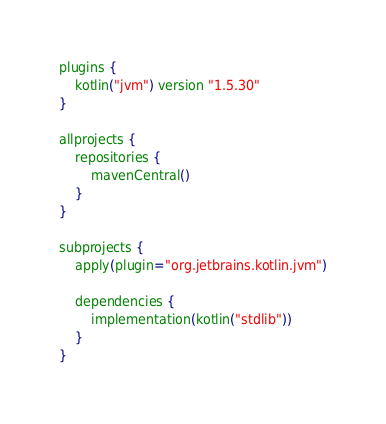Convert code to text. <code><loc_0><loc_0><loc_500><loc_500><_Kotlin_>plugins {
    kotlin("jvm") version "1.5.30"
}

allprojects {
    repositories {
        mavenCentral()
    }
}

subprojects {
    apply(plugin="org.jetbrains.kotlin.jvm")

    dependencies {
        implementation(kotlin("stdlib"))
    }
}</code> 